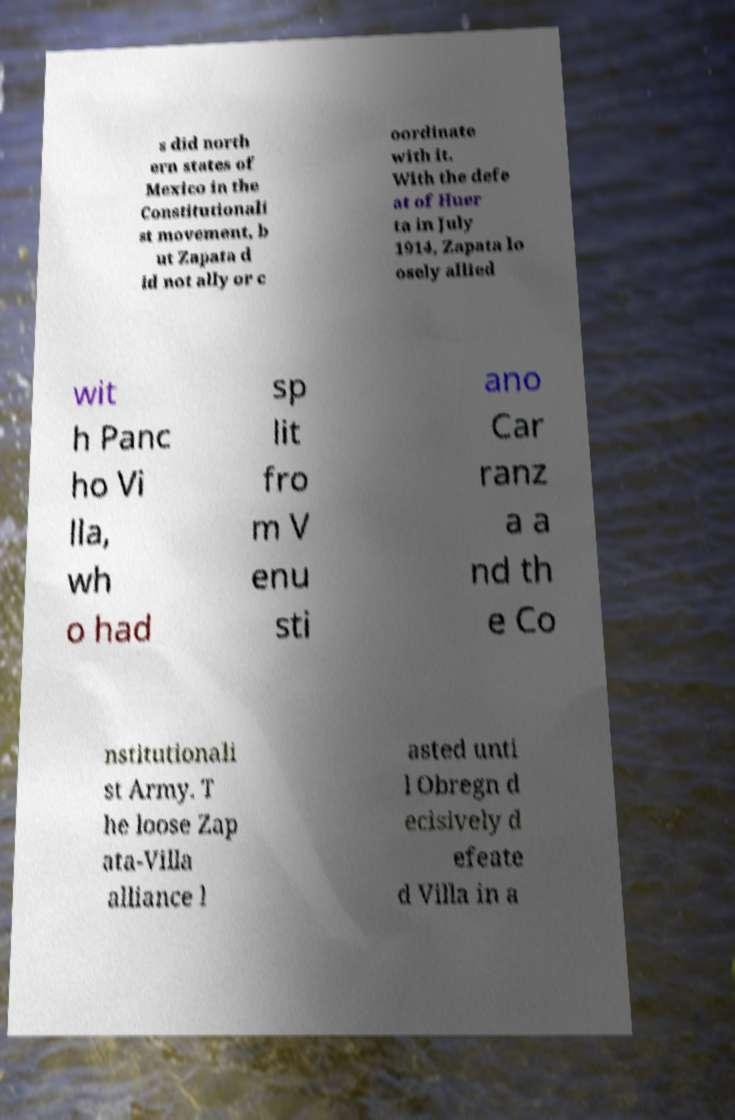Please identify and transcribe the text found in this image. s did north ern states of Mexico in the Constitutionali st movement, b ut Zapata d id not ally or c oordinate with it. With the defe at of Huer ta in July 1914, Zapata lo osely allied wit h Panc ho Vi lla, wh o had sp lit fro m V enu sti ano Car ranz a a nd th e Co nstitutionali st Army. T he loose Zap ata-Villa alliance l asted unti l Obregn d ecisively d efeate d Villa in a 